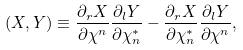Convert formula to latex. <formula><loc_0><loc_0><loc_500><loc_500>( X , Y ) \equiv \frac { \partial _ { r } X } { \partial \chi ^ { n } } \frac { \partial _ { l } Y } { \partial \chi ^ { * } _ { n } } - \frac { \partial _ { r } X } { \partial \chi ^ { * } _ { n } } \frac { \partial _ { l } Y } { \partial \chi ^ { n } } ,</formula> 